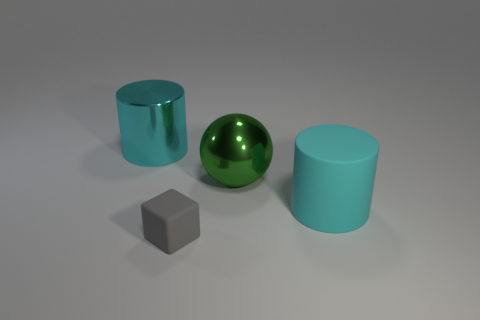What is the arrangement of the objects in relation to each other? The objects are arranged with clear space between them, which provides a sense of order. The green metallic sphere is centered between two cylinders of a cyan hue with different textures, and the tiny gray block is situated in front of them, slightly offset to the left. 